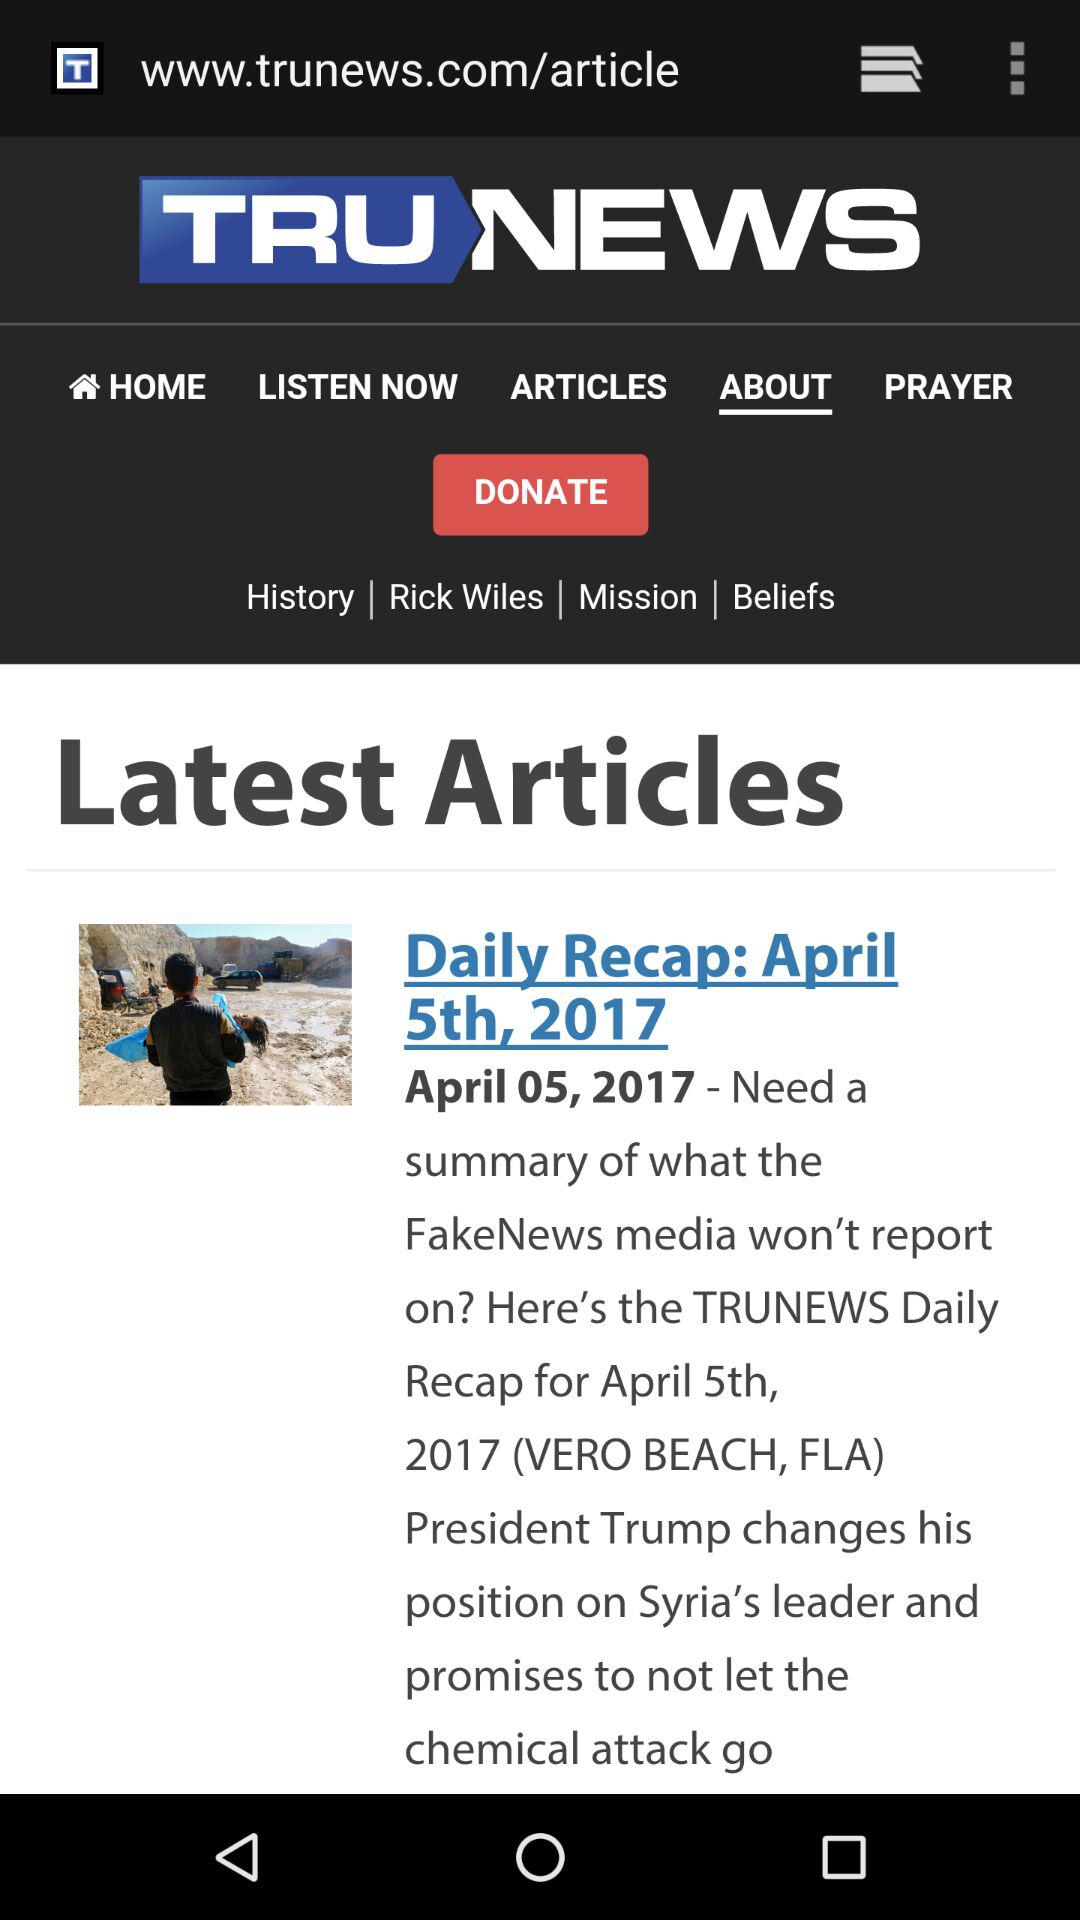On what date were the articles published? The articles were published on April 5th, 2017. 